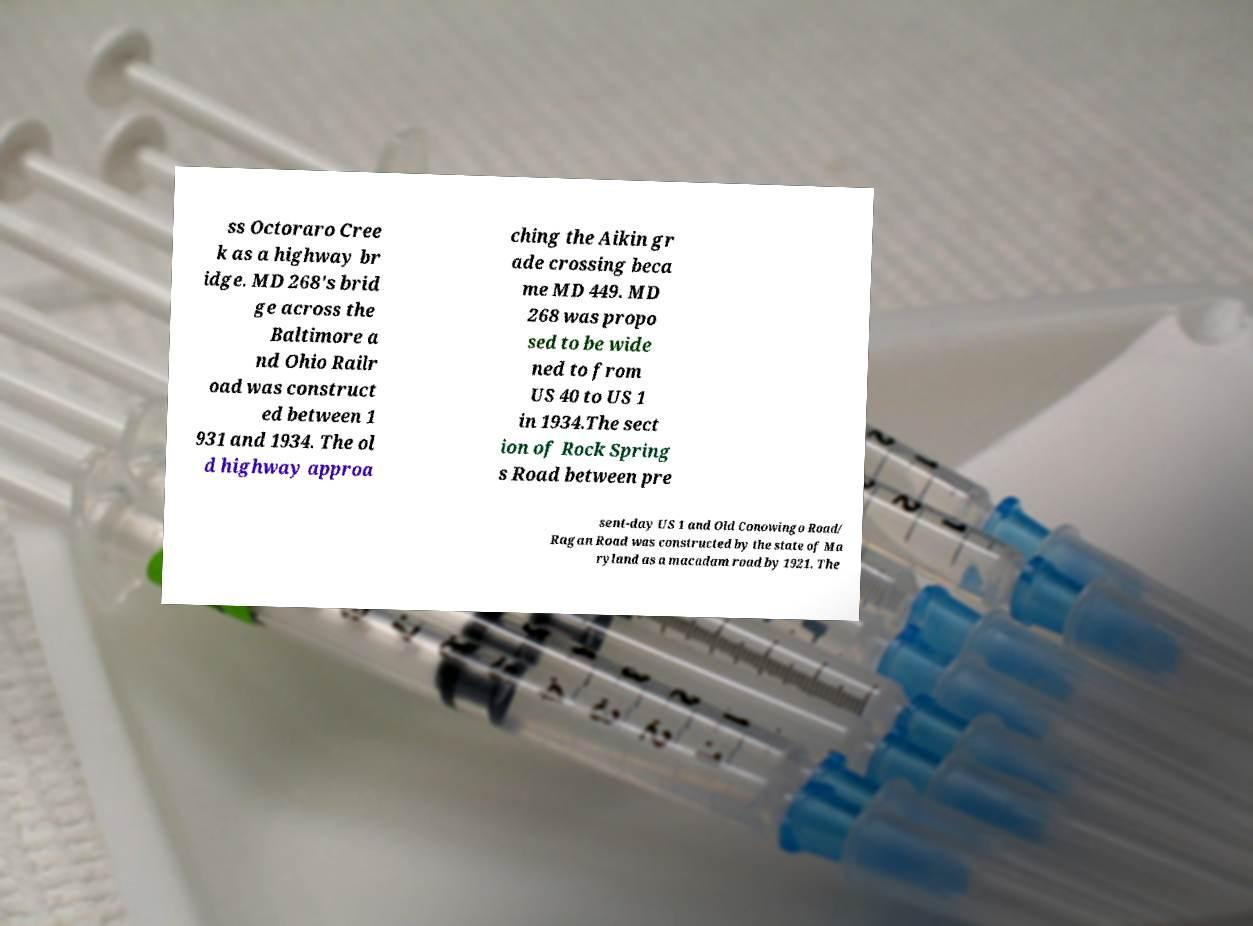What messages or text are displayed in this image? I need them in a readable, typed format. ss Octoraro Cree k as a highway br idge. MD 268's brid ge across the Baltimore a nd Ohio Railr oad was construct ed between 1 931 and 1934. The ol d highway approa ching the Aikin gr ade crossing beca me MD 449. MD 268 was propo sed to be wide ned to from US 40 to US 1 in 1934.The sect ion of Rock Spring s Road between pre sent-day US 1 and Old Conowingo Road/ Ragan Road was constructed by the state of Ma ryland as a macadam road by 1921. The 